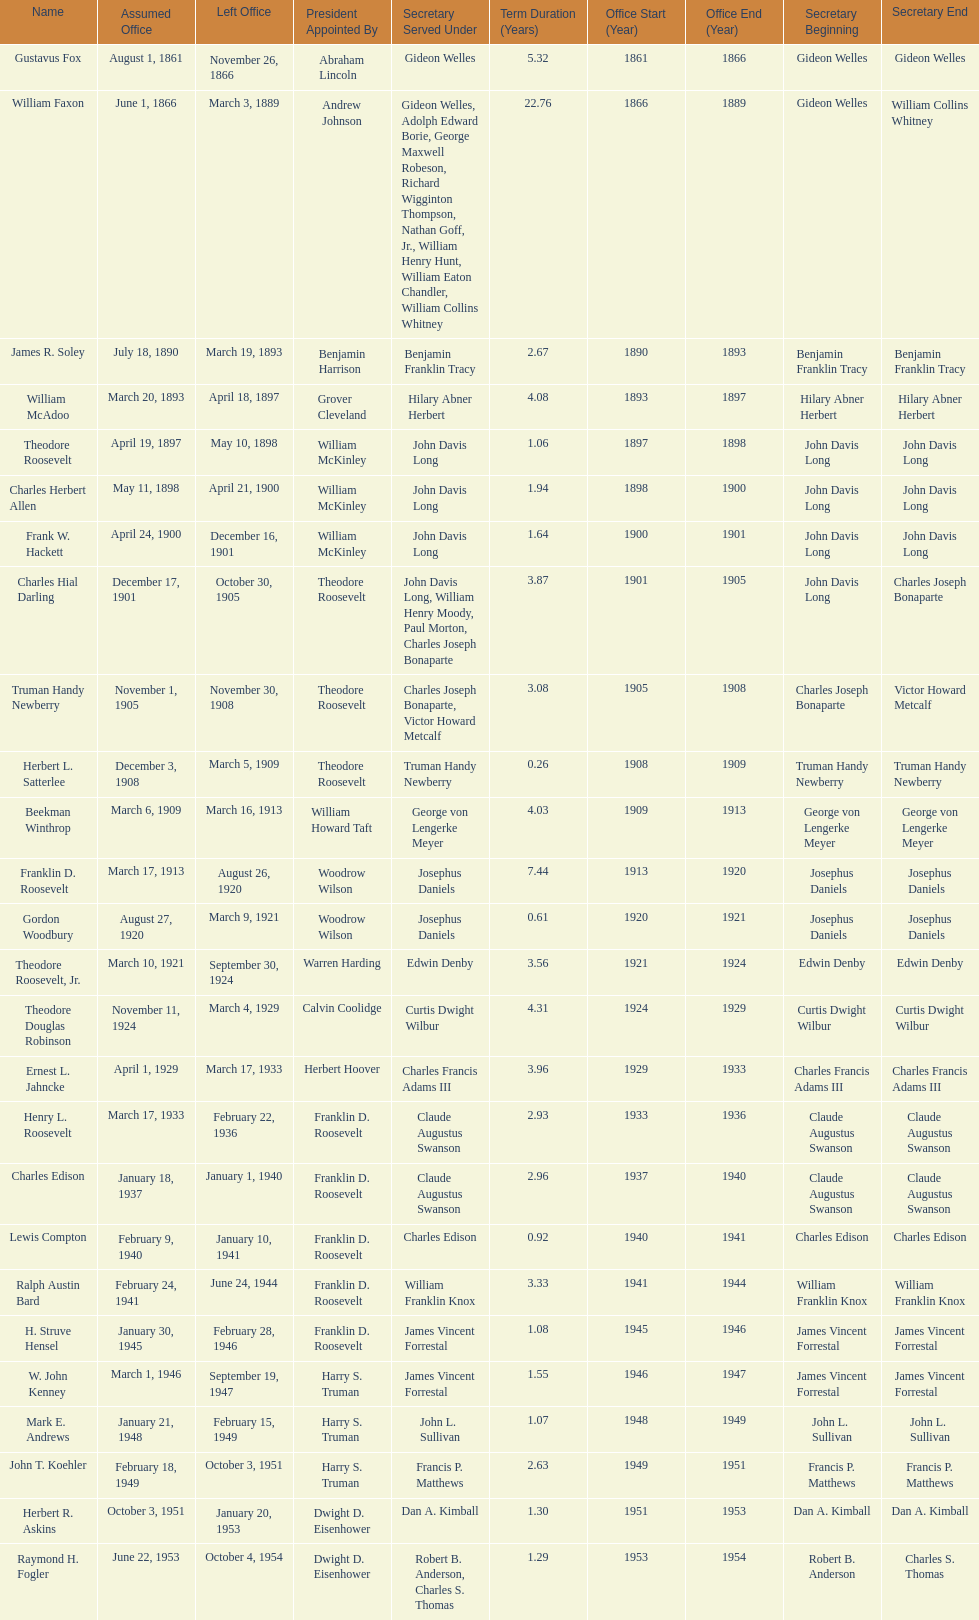When did raymond h. fogler depart from the role of assistant secretary of the navy? October 4, 1954. 